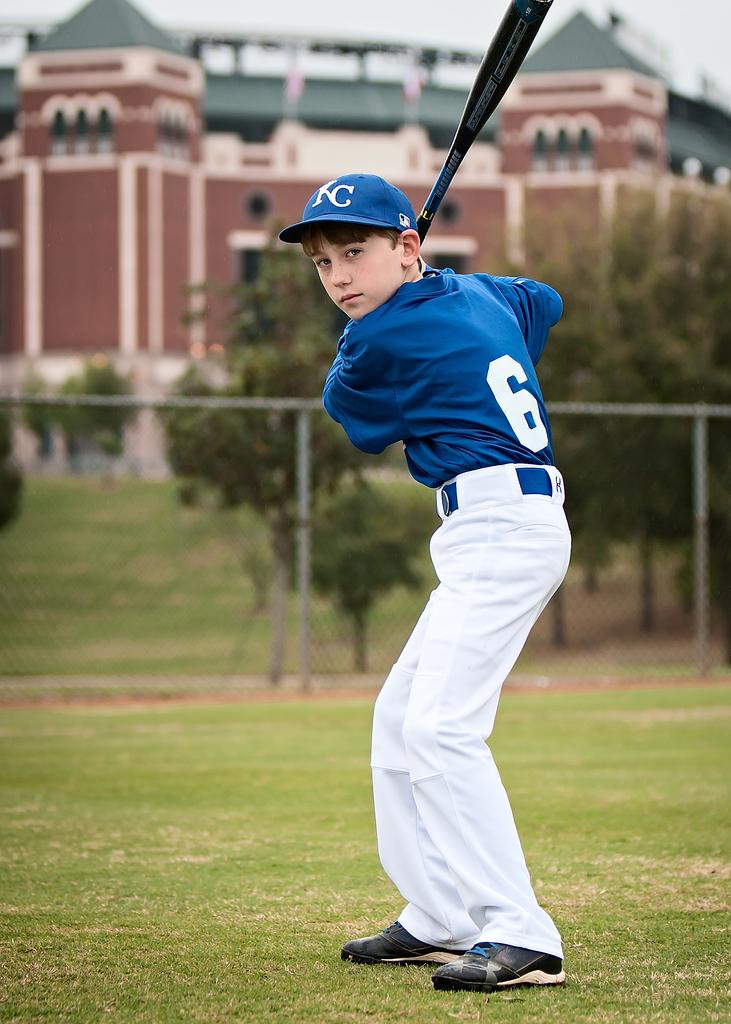Who is the main subject in the image? There is a boy in the image. What is the boy wearing? The boy is wearing a dress and a cap. What is the boy holding in the image? The boy is holding a baseball bat. What can be seen in the background of the image? There is a fence, a group of trees, a building, and the sky visible in the background of the image. What type of pot is the boy using to cover the payment in the image? There is no pot or payment present in the image. 